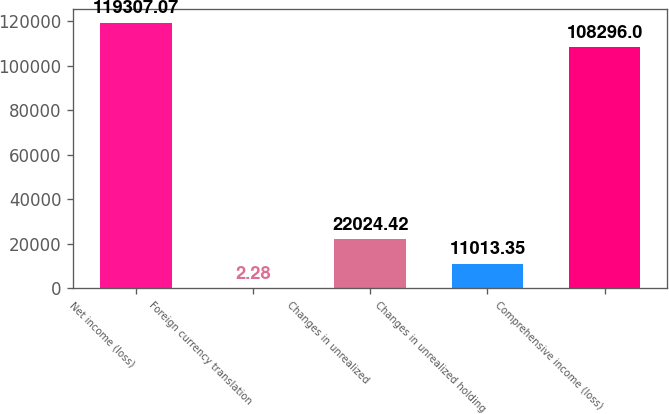Convert chart. <chart><loc_0><loc_0><loc_500><loc_500><bar_chart><fcel>Net income (loss)<fcel>Foreign currency translation<fcel>Changes in unrealized<fcel>Changes in unrealized holding<fcel>Comprehensive income (loss)<nl><fcel>119307<fcel>2.28<fcel>22024.4<fcel>11013.4<fcel>108296<nl></chart> 